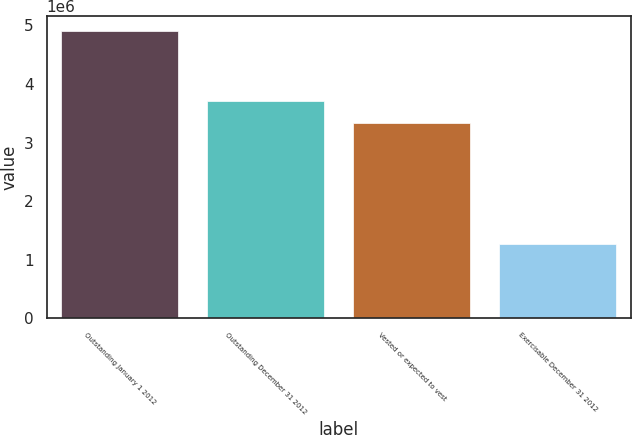<chart> <loc_0><loc_0><loc_500><loc_500><bar_chart><fcel>Outstanding January 1 2012<fcel>Outstanding December 31 2012<fcel>Vested or expected to vest<fcel>Exercisable December 31 2012<nl><fcel>4.90788e+06<fcel>3.70492e+06<fcel>3.34132e+06<fcel>1.27188e+06<nl></chart> 